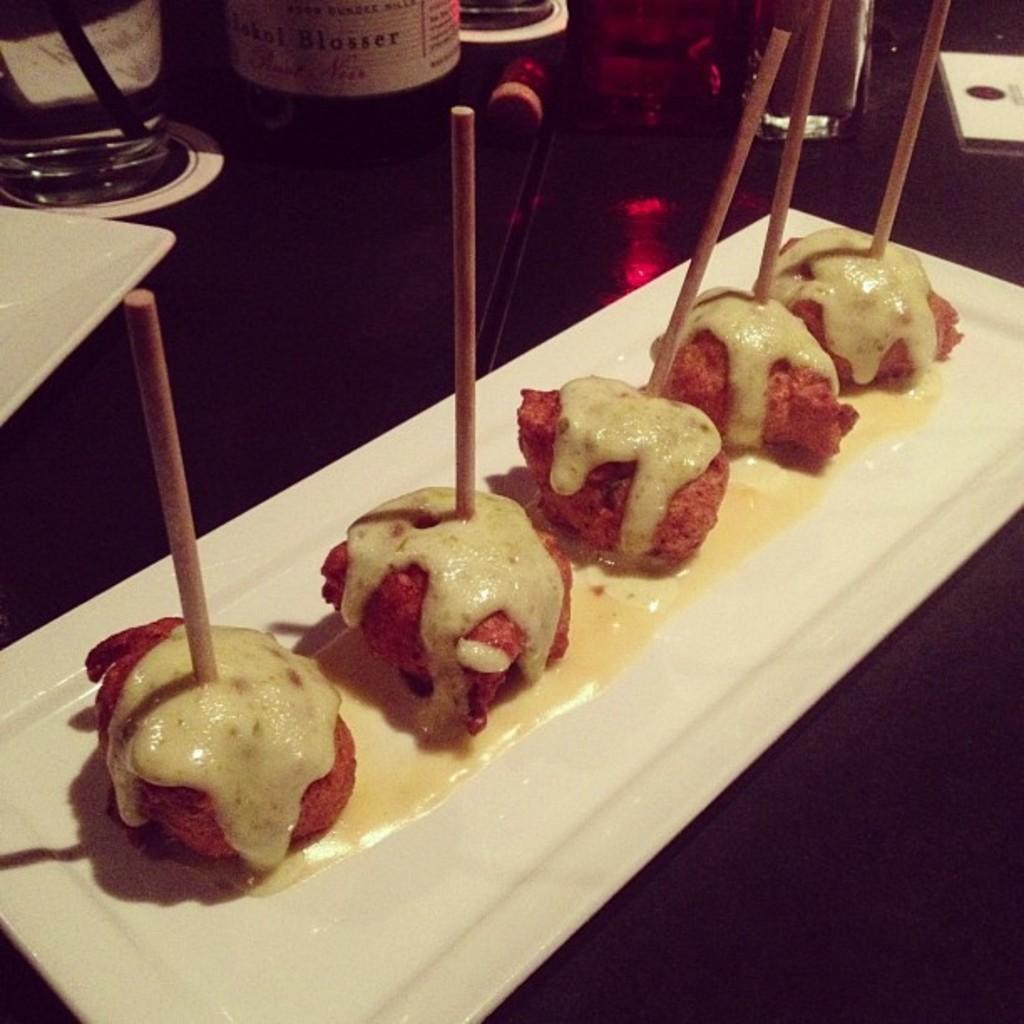In one or two sentences, can you explain what this image depicts? In this image there are food items. On top of it there are sticks in a plate. Beside the plate there are glasses, bottle and a few other objects on the table. 